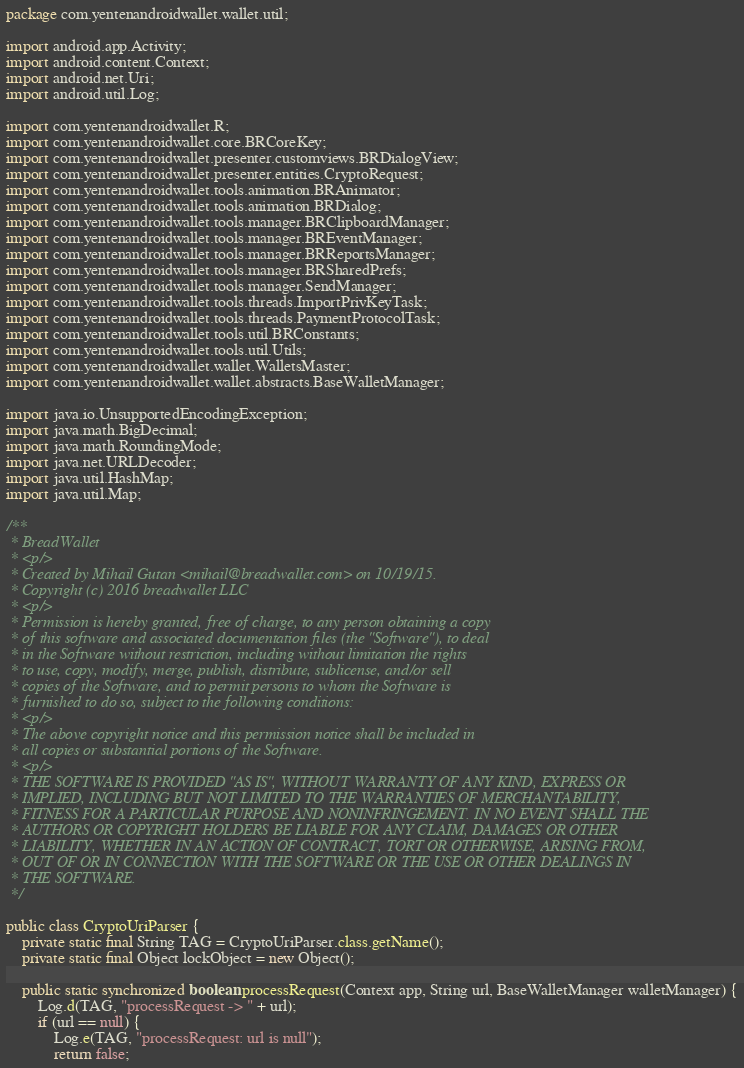Convert code to text. <code><loc_0><loc_0><loc_500><loc_500><_Java_>package com.yentenandroidwallet.wallet.util;

import android.app.Activity;
import android.content.Context;
import android.net.Uri;
import android.util.Log;

import com.yentenandroidwallet.R;
import com.yentenandroidwallet.core.BRCoreKey;
import com.yentenandroidwallet.presenter.customviews.BRDialogView;
import com.yentenandroidwallet.presenter.entities.CryptoRequest;
import com.yentenandroidwallet.tools.animation.BRAnimator;
import com.yentenandroidwallet.tools.animation.BRDialog;
import com.yentenandroidwallet.tools.manager.BRClipboardManager;
import com.yentenandroidwallet.tools.manager.BREventManager;
import com.yentenandroidwallet.tools.manager.BRReportsManager;
import com.yentenandroidwallet.tools.manager.BRSharedPrefs;
import com.yentenandroidwallet.tools.manager.SendManager;
import com.yentenandroidwallet.tools.threads.ImportPrivKeyTask;
import com.yentenandroidwallet.tools.threads.PaymentProtocolTask;
import com.yentenandroidwallet.tools.util.BRConstants;
import com.yentenandroidwallet.tools.util.Utils;
import com.yentenandroidwallet.wallet.WalletsMaster;
import com.yentenandroidwallet.wallet.abstracts.BaseWalletManager;

import java.io.UnsupportedEncodingException;
import java.math.BigDecimal;
import java.math.RoundingMode;
import java.net.URLDecoder;
import java.util.HashMap;
import java.util.Map;

/**
 * BreadWallet
 * <p/>
 * Created by Mihail Gutan <mihail@breadwallet.com> on 10/19/15.
 * Copyright (c) 2016 breadwallet LLC
 * <p/>
 * Permission is hereby granted, free of charge, to any person obtaining a copy
 * of this software and associated documentation files (the "Software"), to deal
 * in the Software without restriction, including without limitation the rights
 * to use, copy, modify, merge, publish, distribute, sublicense, and/or sell
 * copies of the Software, and to permit persons to whom the Software is
 * furnished to do so, subject to the following conditions:
 * <p/>
 * The above copyright notice and this permission notice shall be included in
 * all copies or substantial portions of the Software.
 * <p/>
 * THE SOFTWARE IS PROVIDED "AS IS", WITHOUT WARRANTY OF ANY KIND, EXPRESS OR
 * IMPLIED, INCLUDING BUT NOT LIMITED TO THE WARRANTIES OF MERCHANTABILITY,
 * FITNESS FOR A PARTICULAR PURPOSE AND NONINFRINGEMENT. IN NO EVENT SHALL THE
 * AUTHORS OR COPYRIGHT HOLDERS BE LIABLE FOR ANY CLAIM, DAMAGES OR OTHER
 * LIABILITY, WHETHER IN AN ACTION OF CONTRACT, TORT OR OTHERWISE, ARISING FROM,
 * OUT OF OR IN CONNECTION WITH THE SOFTWARE OR THE USE OR OTHER DEALINGS IN
 * THE SOFTWARE.
 */

public class CryptoUriParser {
    private static final String TAG = CryptoUriParser.class.getName();
    private static final Object lockObject = new Object();

    public static synchronized boolean processRequest(Context app, String url, BaseWalletManager walletManager) {
        Log.d(TAG, "processRequest -> " + url);
        if (url == null) {
            Log.e(TAG, "processRequest: url is null");
            return false;</code> 